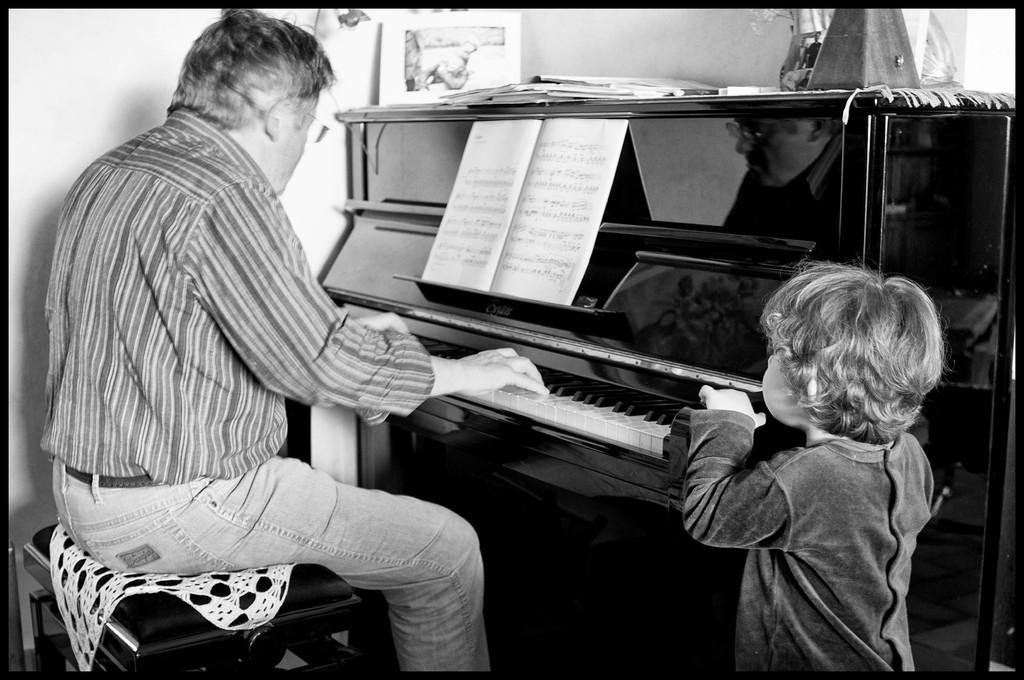What is the person in the image doing? The person is sitting on a stool and playing a piano. What object is in front of the person? There is a book in front of the person. Who else is present in the image? There is a kid beside the person. What type of prose can be heard being read by the person in the image? There is no indication in the image that the person is reading any prose, as they are focused on playing the piano. 